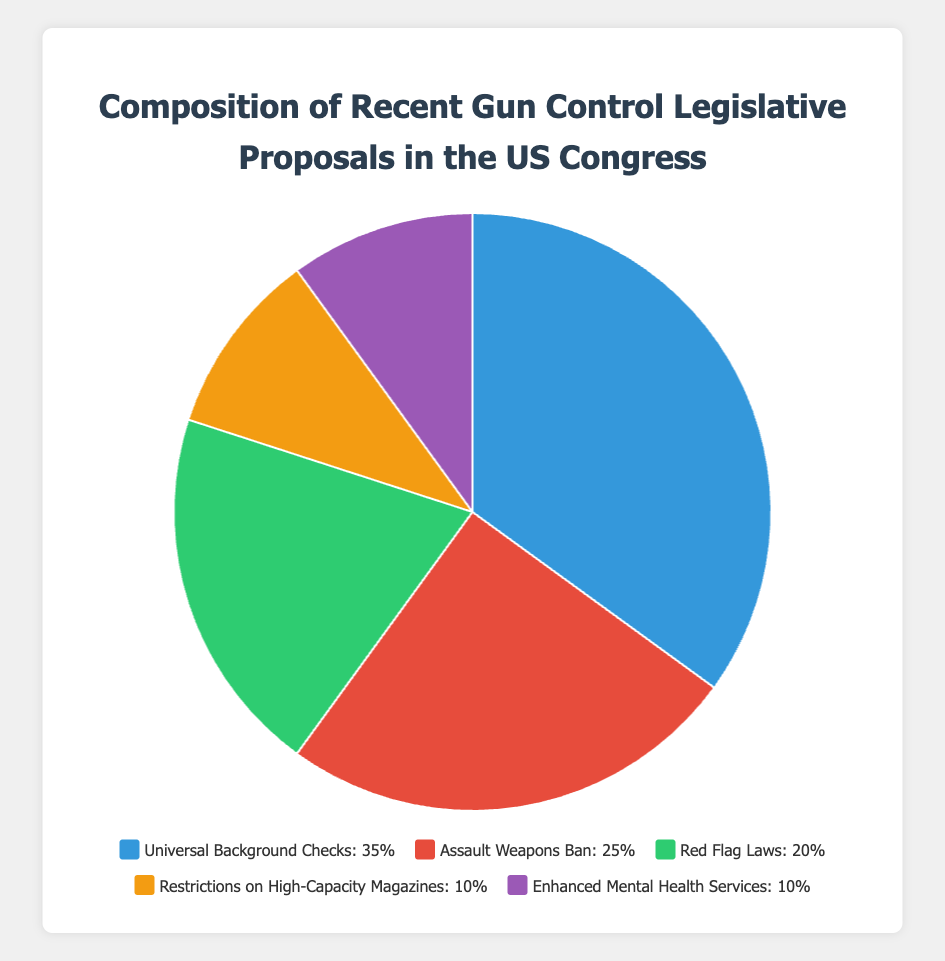What proportion of the legislative proposals is dedicated to enhancing mental health services and restricting high-capacity magazines combined? First, observe the individual percentages for Enhanced Mental Health Services (10%) and Restrictions on High-Capacity Magazines (10%). Then sum these percentages: 10% + 10% = 20%.
Answer: 20% Which category has the highest percentage of legislative proposals? Look at the pie chart to identify the category with the largest segment. Universal Background Checks has a percentage of 35%, which is the highest among the categories listed.
Answer: Universal Background Checks How much more focus is there on Assault Weapons Ban compared to Restrictions on High-Capacity Magazines? First, identify the percentages for Assault Weapons Ban (25%) and Restrictions on High-Capacity Magazines (10%). Subtract the smaller percentage from the larger one: 25% - 10% = 15%.
Answer: 15% Which has a larger share of legislative proposals: Red Flag Laws or Assault Weapons Ban? Compare the two segments' percentages: Red Flag Laws (20%) and Assault Weapons Ban (25%). Since 25% is greater than 20%, Assault Weapons Ban has the larger share.
Answer: Assault Weapons Ban What is the combined total percentage of legislative proposals for Universal Background Checks and Red Flag Laws? First, locate the individual percentages for Universal Background Checks (35%) and Red Flag Laws (20%). Add these together: 35% + 20% = 55%.
Answer: 55% What color represents the category with the smallest percentage? Identify the segments and their associated colors. Both Enhanced Mental Health Services and Restrictions on High-Capacity Magazines are represented by purple and orange respectively, both with a percentage of 10%. Any one of these segments can be considered.
Answer: Purple or Orange Are the percentages for Enhanced Mental Health Services and Restrictions on High-Capacity Magazines equal? Compare the two percentages directly: Enhanced Mental Health Services (10%) and Restrictions on High-Capacity Magazines (10%). Since they both are 10%, they are equal.
Answer: Yes How much focus is given to Universal Background Checks and Assault Weapons Ban combined compared to Red Flag Laws? First, sum the percentages of Universal Background Checks and Assault Weapons Ban: 35% + 25% = 60%. Then, compare this combined sum (60%) to the percentage for Red Flag Laws (20%).
Answer: 60% vs 20% What is the least focused category in the legislative proposals? Identify the segments with the smallest individual percentages. Both Enhanced Mental Health Services and Restrictions on High-Capacity Magazines have 10%, which are the smallest percentages in the pie chart.
Answer: Enhanced Mental Health Services and Restrictions on High-Capacity Magazines What is the average percentage of all legislative proposals? First, sum up all the percentages: 35% (Universal Background Checks) + 25% (Assault Weapons Ban) + 20% (Red Flag Laws) +10% (Restrictions on High-Capacity Magazines) + 10% (Enhanced Mental Health Services) = 100%. Then, divide by the number of categories (5): 100% / 5 = 20%.
Answer: 20% 